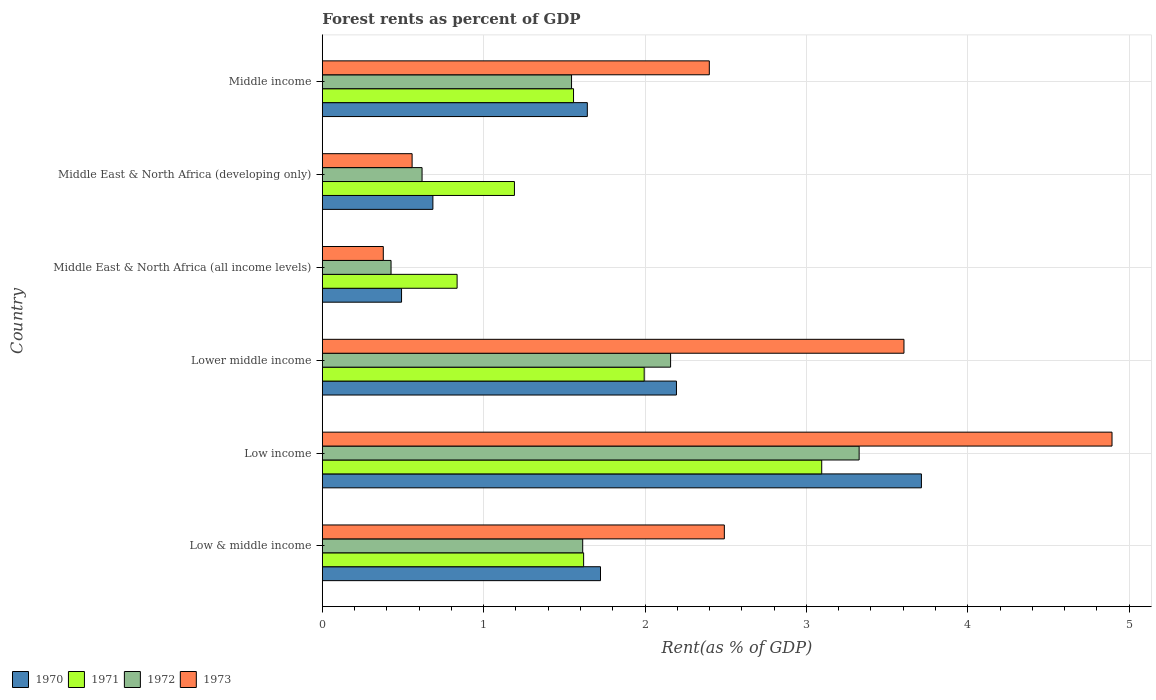Are the number of bars on each tick of the Y-axis equal?
Give a very brief answer. Yes. How many bars are there on the 1st tick from the top?
Give a very brief answer. 4. What is the label of the 3rd group of bars from the top?
Give a very brief answer. Middle East & North Africa (all income levels). What is the forest rent in 1970 in Middle East & North Africa (developing only)?
Your answer should be very brief. 0.69. Across all countries, what is the maximum forest rent in 1970?
Your response must be concise. 3.71. Across all countries, what is the minimum forest rent in 1971?
Provide a short and direct response. 0.84. In which country was the forest rent in 1973 minimum?
Your answer should be very brief. Middle East & North Africa (all income levels). What is the total forest rent in 1973 in the graph?
Your answer should be very brief. 14.32. What is the difference between the forest rent in 1973 in Low income and that in Middle East & North Africa (developing only)?
Provide a succinct answer. 4.34. What is the difference between the forest rent in 1972 in Lower middle income and the forest rent in 1970 in Middle East & North Africa (developing only)?
Give a very brief answer. 1.47. What is the average forest rent in 1970 per country?
Provide a short and direct response. 1.74. What is the difference between the forest rent in 1970 and forest rent in 1973 in Low & middle income?
Your answer should be compact. -0.77. What is the ratio of the forest rent in 1973 in Middle East & North Africa (all income levels) to that in Middle income?
Your answer should be very brief. 0.16. Is the forest rent in 1972 in Low & middle income less than that in Lower middle income?
Make the answer very short. Yes. Is the difference between the forest rent in 1970 in Low & middle income and Middle East & North Africa (developing only) greater than the difference between the forest rent in 1973 in Low & middle income and Middle East & North Africa (developing only)?
Your answer should be compact. No. What is the difference between the highest and the second highest forest rent in 1973?
Ensure brevity in your answer.  1.29. What is the difference between the highest and the lowest forest rent in 1972?
Your answer should be compact. 2.9. In how many countries, is the forest rent in 1973 greater than the average forest rent in 1973 taken over all countries?
Your answer should be compact. 4. Is the sum of the forest rent in 1973 in Low & middle income and Lower middle income greater than the maximum forest rent in 1970 across all countries?
Your response must be concise. Yes. Is it the case that in every country, the sum of the forest rent in 1972 and forest rent in 1971 is greater than the sum of forest rent in 1973 and forest rent in 1970?
Keep it short and to the point. No. What does the 2nd bar from the bottom in Low & middle income represents?
Provide a succinct answer. 1971. Is it the case that in every country, the sum of the forest rent in 1970 and forest rent in 1973 is greater than the forest rent in 1972?
Provide a succinct answer. Yes. Are all the bars in the graph horizontal?
Offer a very short reply. Yes. Does the graph contain any zero values?
Provide a succinct answer. No. Where does the legend appear in the graph?
Your response must be concise. Bottom left. How many legend labels are there?
Ensure brevity in your answer.  4. How are the legend labels stacked?
Ensure brevity in your answer.  Horizontal. What is the title of the graph?
Keep it short and to the point. Forest rents as percent of GDP. What is the label or title of the X-axis?
Ensure brevity in your answer.  Rent(as % of GDP). What is the Rent(as % of GDP) in 1970 in Low & middle income?
Provide a succinct answer. 1.72. What is the Rent(as % of GDP) of 1971 in Low & middle income?
Ensure brevity in your answer.  1.62. What is the Rent(as % of GDP) in 1972 in Low & middle income?
Offer a very short reply. 1.61. What is the Rent(as % of GDP) of 1973 in Low & middle income?
Give a very brief answer. 2.49. What is the Rent(as % of GDP) of 1970 in Low income?
Give a very brief answer. 3.71. What is the Rent(as % of GDP) of 1971 in Low income?
Keep it short and to the point. 3.09. What is the Rent(as % of GDP) in 1972 in Low income?
Your response must be concise. 3.33. What is the Rent(as % of GDP) of 1973 in Low income?
Make the answer very short. 4.89. What is the Rent(as % of GDP) in 1970 in Lower middle income?
Offer a very short reply. 2.19. What is the Rent(as % of GDP) in 1971 in Lower middle income?
Provide a succinct answer. 1.99. What is the Rent(as % of GDP) of 1972 in Lower middle income?
Offer a very short reply. 2.16. What is the Rent(as % of GDP) in 1973 in Lower middle income?
Make the answer very short. 3.6. What is the Rent(as % of GDP) in 1970 in Middle East & North Africa (all income levels)?
Your answer should be compact. 0.49. What is the Rent(as % of GDP) of 1971 in Middle East & North Africa (all income levels)?
Keep it short and to the point. 0.84. What is the Rent(as % of GDP) in 1972 in Middle East & North Africa (all income levels)?
Provide a succinct answer. 0.43. What is the Rent(as % of GDP) of 1973 in Middle East & North Africa (all income levels)?
Your response must be concise. 0.38. What is the Rent(as % of GDP) of 1970 in Middle East & North Africa (developing only)?
Offer a very short reply. 0.69. What is the Rent(as % of GDP) in 1971 in Middle East & North Africa (developing only)?
Make the answer very short. 1.19. What is the Rent(as % of GDP) of 1972 in Middle East & North Africa (developing only)?
Offer a terse response. 0.62. What is the Rent(as % of GDP) of 1973 in Middle East & North Africa (developing only)?
Offer a very short reply. 0.56. What is the Rent(as % of GDP) of 1970 in Middle income?
Give a very brief answer. 1.64. What is the Rent(as % of GDP) of 1971 in Middle income?
Your response must be concise. 1.56. What is the Rent(as % of GDP) in 1972 in Middle income?
Keep it short and to the point. 1.54. What is the Rent(as % of GDP) of 1973 in Middle income?
Give a very brief answer. 2.4. Across all countries, what is the maximum Rent(as % of GDP) in 1970?
Provide a succinct answer. 3.71. Across all countries, what is the maximum Rent(as % of GDP) in 1971?
Offer a terse response. 3.09. Across all countries, what is the maximum Rent(as % of GDP) of 1972?
Your answer should be very brief. 3.33. Across all countries, what is the maximum Rent(as % of GDP) of 1973?
Your response must be concise. 4.89. Across all countries, what is the minimum Rent(as % of GDP) in 1970?
Provide a short and direct response. 0.49. Across all countries, what is the minimum Rent(as % of GDP) in 1971?
Make the answer very short. 0.84. Across all countries, what is the minimum Rent(as % of GDP) of 1972?
Offer a terse response. 0.43. Across all countries, what is the minimum Rent(as % of GDP) of 1973?
Make the answer very short. 0.38. What is the total Rent(as % of GDP) of 1970 in the graph?
Provide a short and direct response. 10.45. What is the total Rent(as % of GDP) in 1971 in the graph?
Keep it short and to the point. 10.29. What is the total Rent(as % of GDP) of 1972 in the graph?
Offer a terse response. 9.69. What is the total Rent(as % of GDP) of 1973 in the graph?
Provide a succinct answer. 14.32. What is the difference between the Rent(as % of GDP) of 1970 in Low & middle income and that in Low income?
Provide a succinct answer. -1.99. What is the difference between the Rent(as % of GDP) of 1971 in Low & middle income and that in Low income?
Ensure brevity in your answer.  -1.48. What is the difference between the Rent(as % of GDP) in 1972 in Low & middle income and that in Low income?
Your answer should be very brief. -1.71. What is the difference between the Rent(as % of GDP) of 1973 in Low & middle income and that in Low income?
Your answer should be very brief. -2.4. What is the difference between the Rent(as % of GDP) in 1970 in Low & middle income and that in Lower middle income?
Your response must be concise. -0.47. What is the difference between the Rent(as % of GDP) in 1971 in Low & middle income and that in Lower middle income?
Give a very brief answer. -0.38. What is the difference between the Rent(as % of GDP) of 1972 in Low & middle income and that in Lower middle income?
Ensure brevity in your answer.  -0.54. What is the difference between the Rent(as % of GDP) of 1973 in Low & middle income and that in Lower middle income?
Ensure brevity in your answer.  -1.11. What is the difference between the Rent(as % of GDP) in 1970 in Low & middle income and that in Middle East & North Africa (all income levels)?
Make the answer very short. 1.23. What is the difference between the Rent(as % of GDP) in 1971 in Low & middle income and that in Middle East & North Africa (all income levels)?
Make the answer very short. 0.78. What is the difference between the Rent(as % of GDP) of 1972 in Low & middle income and that in Middle East & North Africa (all income levels)?
Your answer should be compact. 1.19. What is the difference between the Rent(as % of GDP) of 1973 in Low & middle income and that in Middle East & North Africa (all income levels)?
Ensure brevity in your answer.  2.11. What is the difference between the Rent(as % of GDP) of 1970 in Low & middle income and that in Middle East & North Africa (developing only)?
Provide a short and direct response. 1.04. What is the difference between the Rent(as % of GDP) in 1971 in Low & middle income and that in Middle East & North Africa (developing only)?
Your answer should be compact. 0.43. What is the difference between the Rent(as % of GDP) in 1973 in Low & middle income and that in Middle East & North Africa (developing only)?
Make the answer very short. 1.93. What is the difference between the Rent(as % of GDP) in 1970 in Low & middle income and that in Middle income?
Provide a succinct answer. 0.08. What is the difference between the Rent(as % of GDP) in 1971 in Low & middle income and that in Middle income?
Offer a very short reply. 0.06. What is the difference between the Rent(as % of GDP) of 1972 in Low & middle income and that in Middle income?
Your answer should be very brief. 0.07. What is the difference between the Rent(as % of GDP) of 1973 in Low & middle income and that in Middle income?
Offer a terse response. 0.09. What is the difference between the Rent(as % of GDP) in 1970 in Low income and that in Lower middle income?
Provide a succinct answer. 1.52. What is the difference between the Rent(as % of GDP) in 1971 in Low income and that in Lower middle income?
Your response must be concise. 1.1. What is the difference between the Rent(as % of GDP) of 1972 in Low income and that in Lower middle income?
Keep it short and to the point. 1.17. What is the difference between the Rent(as % of GDP) in 1973 in Low income and that in Lower middle income?
Your answer should be very brief. 1.29. What is the difference between the Rent(as % of GDP) in 1970 in Low income and that in Middle East & North Africa (all income levels)?
Your answer should be compact. 3.22. What is the difference between the Rent(as % of GDP) in 1971 in Low income and that in Middle East & North Africa (all income levels)?
Offer a very short reply. 2.26. What is the difference between the Rent(as % of GDP) of 1972 in Low income and that in Middle East & North Africa (all income levels)?
Give a very brief answer. 2.9. What is the difference between the Rent(as % of GDP) of 1973 in Low income and that in Middle East & North Africa (all income levels)?
Offer a very short reply. 4.52. What is the difference between the Rent(as % of GDP) of 1970 in Low income and that in Middle East & North Africa (developing only)?
Make the answer very short. 3.03. What is the difference between the Rent(as % of GDP) of 1971 in Low income and that in Middle East & North Africa (developing only)?
Provide a succinct answer. 1.9. What is the difference between the Rent(as % of GDP) of 1972 in Low income and that in Middle East & North Africa (developing only)?
Your response must be concise. 2.71. What is the difference between the Rent(as % of GDP) in 1973 in Low income and that in Middle East & North Africa (developing only)?
Your response must be concise. 4.34. What is the difference between the Rent(as % of GDP) of 1970 in Low income and that in Middle income?
Your answer should be compact. 2.07. What is the difference between the Rent(as % of GDP) of 1971 in Low income and that in Middle income?
Keep it short and to the point. 1.54. What is the difference between the Rent(as % of GDP) in 1972 in Low income and that in Middle income?
Offer a very short reply. 1.78. What is the difference between the Rent(as % of GDP) in 1973 in Low income and that in Middle income?
Offer a very short reply. 2.5. What is the difference between the Rent(as % of GDP) in 1970 in Lower middle income and that in Middle East & North Africa (all income levels)?
Ensure brevity in your answer.  1.7. What is the difference between the Rent(as % of GDP) of 1971 in Lower middle income and that in Middle East & North Africa (all income levels)?
Ensure brevity in your answer.  1.16. What is the difference between the Rent(as % of GDP) of 1972 in Lower middle income and that in Middle East & North Africa (all income levels)?
Ensure brevity in your answer.  1.73. What is the difference between the Rent(as % of GDP) of 1973 in Lower middle income and that in Middle East & North Africa (all income levels)?
Your response must be concise. 3.23. What is the difference between the Rent(as % of GDP) of 1970 in Lower middle income and that in Middle East & North Africa (developing only)?
Your response must be concise. 1.51. What is the difference between the Rent(as % of GDP) of 1971 in Lower middle income and that in Middle East & North Africa (developing only)?
Provide a short and direct response. 0.8. What is the difference between the Rent(as % of GDP) in 1972 in Lower middle income and that in Middle East & North Africa (developing only)?
Ensure brevity in your answer.  1.54. What is the difference between the Rent(as % of GDP) in 1973 in Lower middle income and that in Middle East & North Africa (developing only)?
Give a very brief answer. 3.05. What is the difference between the Rent(as % of GDP) of 1970 in Lower middle income and that in Middle income?
Ensure brevity in your answer.  0.55. What is the difference between the Rent(as % of GDP) in 1971 in Lower middle income and that in Middle income?
Provide a succinct answer. 0.44. What is the difference between the Rent(as % of GDP) of 1972 in Lower middle income and that in Middle income?
Provide a succinct answer. 0.61. What is the difference between the Rent(as % of GDP) in 1973 in Lower middle income and that in Middle income?
Provide a short and direct response. 1.21. What is the difference between the Rent(as % of GDP) of 1970 in Middle East & North Africa (all income levels) and that in Middle East & North Africa (developing only)?
Offer a terse response. -0.19. What is the difference between the Rent(as % of GDP) in 1971 in Middle East & North Africa (all income levels) and that in Middle East & North Africa (developing only)?
Provide a succinct answer. -0.36. What is the difference between the Rent(as % of GDP) in 1972 in Middle East & North Africa (all income levels) and that in Middle East & North Africa (developing only)?
Keep it short and to the point. -0.19. What is the difference between the Rent(as % of GDP) of 1973 in Middle East & North Africa (all income levels) and that in Middle East & North Africa (developing only)?
Offer a very short reply. -0.18. What is the difference between the Rent(as % of GDP) of 1970 in Middle East & North Africa (all income levels) and that in Middle income?
Ensure brevity in your answer.  -1.15. What is the difference between the Rent(as % of GDP) of 1971 in Middle East & North Africa (all income levels) and that in Middle income?
Provide a short and direct response. -0.72. What is the difference between the Rent(as % of GDP) in 1972 in Middle East & North Africa (all income levels) and that in Middle income?
Give a very brief answer. -1.12. What is the difference between the Rent(as % of GDP) of 1973 in Middle East & North Africa (all income levels) and that in Middle income?
Offer a terse response. -2.02. What is the difference between the Rent(as % of GDP) in 1970 in Middle East & North Africa (developing only) and that in Middle income?
Give a very brief answer. -0.96. What is the difference between the Rent(as % of GDP) of 1971 in Middle East & North Africa (developing only) and that in Middle income?
Keep it short and to the point. -0.37. What is the difference between the Rent(as % of GDP) of 1972 in Middle East & North Africa (developing only) and that in Middle income?
Ensure brevity in your answer.  -0.93. What is the difference between the Rent(as % of GDP) of 1973 in Middle East & North Africa (developing only) and that in Middle income?
Provide a succinct answer. -1.84. What is the difference between the Rent(as % of GDP) of 1970 in Low & middle income and the Rent(as % of GDP) of 1971 in Low income?
Make the answer very short. -1.37. What is the difference between the Rent(as % of GDP) of 1970 in Low & middle income and the Rent(as % of GDP) of 1972 in Low income?
Give a very brief answer. -1.6. What is the difference between the Rent(as % of GDP) of 1970 in Low & middle income and the Rent(as % of GDP) of 1973 in Low income?
Your response must be concise. -3.17. What is the difference between the Rent(as % of GDP) of 1971 in Low & middle income and the Rent(as % of GDP) of 1972 in Low income?
Ensure brevity in your answer.  -1.71. What is the difference between the Rent(as % of GDP) of 1971 in Low & middle income and the Rent(as % of GDP) of 1973 in Low income?
Offer a very short reply. -3.27. What is the difference between the Rent(as % of GDP) in 1972 in Low & middle income and the Rent(as % of GDP) in 1973 in Low income?
Offer a very short reply. -3.28. What is the difference between the Rent(as % of GDP) in 1970 in Low & middle income and the Rent(as % of GDP) in 1971 in Lower middle income?
Give a very brief answer. -0.27. What is the difference between the Rent(as % of GDP) of 1970 in Low & middle income and the Rent(as % of GDP) of 1972 in Lower middle income?
Ensure brevity in your answer.  -0.43. What is the difference between the Rent(as % of GDP) of 1970 in Low & middle income and the Rent(as % of GDP) of 1973 in Lower middle income?
Ensure brevity in your answer.  -1.88. What is the difference between the Rent(as % of GDP) in 1971 in Low & middle income and the Rent(as % of GDP) in 1972 in Lower middle income?
Provide a succinct answer. -0.54. What is the difference between the Rent(as % of GDP) in 1971 in Low & middle income and the Rent(as % of GDP) in 1973 in Lower middle income?
Make the answer very short. -1.99. What is the difference between the Rent(as % of GDP) in 1972 in Low & middle income and the Rent(as % of GDP) in 1973 in Lower middle income?
Provide a short and direct response. -1.99. What is the difference between the Rent(as % of GDP) of 1970 in Low & middle income and the Rent(as % of GDP) of 1971 in Middle East & North Africa (all income levels)?
Offer a very short reply. 0.89. What is the difference between the Rent(as % of GDP) of 1970 in Low & middle income and the Rent(as % of GDP) of 1972 in Middle East & North Africa (all income levels)?
Make the answer very short. 1.3. What is the difference between the Rent(as % of GDP) of 1970 in Low & middle income and the Rent(as % of GDP) of 1973 in Middle East & North Africa (all income levels)?
Your answer should be very brief. 1.35. What is the difference between the Rent(as % of GDP) of 1971 in Low & middle income and the Rent(as % of GDP) of 1972 in Middle East & North Africa (all income levels)?
Your response must be concise. 1.19. What is the difference between the Rent(as % of GDP) in 1971 in Low & middle income and the Rent(as % of GDP) in 1973 in Middle East & North Africa (all income levels)?
Make the answer very short. 1.24. What is the difference between the Rent(as % of GDP) in 1972 in Low & middle income and the Rent(as % of GDP) in 1973 in Middle East & North Africa (all income levels)?
Your response must be concise. 1.24. What is the difference between the Rent(as % of GDP) of 1970 in Low & middle income and the Rent(as % of GDP) of 1971 in Middle East & North Africa (developing only)?
Provide a succinct answer. 0.53. What is the difference between the Rent(as % of GDP) in 1970 in Low & middle income and the Rent(as % of GDP) in 1972 in Middle East & North Africa (developing only)?
Your answer should be compact. 1.11. What is the difference between the Rent(as % of GDP) of 1970 in Low & middle income and the Rent(as % of GDP) of 1973 in Middle East & North Africa (developing only)?
Offer a terse response. 1.17. What is the difference between the Rent(as % of GDP) of 1971 in Low & middle income and the Rent(as % of GDP) of 1972 in Middle East & North Africa (developing only)?
Make the answer very short. 1. What is the difference between the Rent(as % of GDP) in 1971 in Low & middle income and the Rent(as % of GDP) in 1973 in Middle East & North Africa (developing only)?
Give a very brief answer. 1.06. What is the difference between the Rent(as % of GDP) of 1972 in Low & middle income and the Rent(as % of GDP) of 1973 in Middle East & North Africa (developing only)?
Give a very brief answer. 1.06. What is the difference between the Rent(as % of GDP) in 1970 in Low & middle income and the Rent(as % of GDP) in 1971 in Middle income?
Give a very brief answer. 0.17. What is the difference between the Rent(as % of GDP) in 1970 in Low & middle income and the Rent(as % of GDP) in 1972 in Middle income?
Your answer should be compact. 0.18. What is the difference between the Rent(as % of GDP) of 1970 in Low & middle income and the Rent(as % of GDP) of 1973 in Middle income?
Offer a very short reply. -0.67. What is the difference between the Rent(as % of GDP) in 1971 in Low & middle income and the Rent(as % of GDP) in 1972 in Middle income?
Offer a very short reply. 0.07. What is the difference between the Rent(as % of GDP) of 1971 in Low & middle income and the Rent(as % of GDP) of 1973 in Middle income?
Offer a terse response. -0.78. What is the difference between the Rent(as % of GDP) of 1972 in Low & middle income and the Rent(as % of GDP) of 1973 in Middle income?
Offer a very short reply. -0.78. What is the difference between the Rent(as % of GDP) of 1970 in Low income and the Rent(as % of GDP) of 1971 in Lower middle income?
Your answer should be compact. 1.72. What is the difference between the Rent(as % of GDP) of 1970 in Low income and the Rent(as % of GDP) of 1972 in Lower middle income?
Offer a terse response. 1.55. What is the difference between the Rent(as % of GDP) in 1970 in Low income and the Rent(as % of GDP) in 1973 in Lower middle income?
Keep it short and to the point. 0.11. What is the difference between the Rent(as % of GDP) in 1971 in Low income and the Rent(as % of GDP) in 1972 in Lower middle income?
Your answer should be compact. 0.94. What is the difference between the Rent(as % of GDP) of 1971 in Low income and the Rent(as % of GDP) of 1973 in Lower middle income?
Provide a succinct answer. -0.51. What is the difference between the Rent(as % of GDP) in 1972 in Low income and the Rent(as % of GDP) in 1973 in Lower middle income?
Offer a very short reply. -0.28. What is the difference between the Rent(as % of GDP) of 1970 in Low income and the Rent(as % of GDP) of 1971 in Middle East & North Africa (all income levels)?
Offer a very short reply. 2.88. What is the difference between the Rent(as % of GDP) of 1970 in Low income and the Rent(as % of GDP) of 1972 in Middle East & North Africa (all income levels)?
Offer a terse response. 3.29. What is the difference between the Rent(as % of GDP) of 1970 in Low income and the Rent(as % of GDP) of 1973 in Middle East & North Africa (all income levels)?
Make the answer very short. 3.33. What is the difference between the Rent(as % of GDP) of 1971 in Low income and the Rent(as % of GDP) of 1972 in Middle East & North Africa (all income levels)?
Provide a succinct answer. 2.67. What is the difference between the Rent(as % of GDP) of 1971 in Low income and the Rent(as % of GDP) of 1973 in Middle East & North Africa (all income levels)?
Provide a succinct answer. 2.72. What is the difference between the Rent(as % of GDP) of 1972 in Low income and the Rent(as % of GDP) of 1973 in Middle East & North Africa (all income levels)?
Your answer should be very brief. 2.95. What is the difference between the Rent(as % of GDP) of 1970 in Low income and the Rent(as % of GDP) of 1971 in Middle East & North Africa (developing only)?
Make the answer very short. 2.52. What is the difference between the Rent(as % of GDP) of 1970 in Low income and the Rent(as % of GDP) of 1972 in Middle East & North Africa (developing only)?
Keep it short and to the point. 3.09. What is the difference between the Rent(as % of GDP) of 1970 in Low income and the Rent(as % of GDP) of 1973 in Middle East & North Africa (developing only)?
Keep it short and to the point. 3.16. What is the difference between the Rent(as % of GDP) in 1971 in Low income and the Rent(as % of GDP) in 1972 in Middle East & North Africa (developing only)?
Keep it short and to the point. 2.48. What is the difference between the Rent(as % of GDP) in 1971 in Low income and the Rent(as % of GDP) in 1973 in Middle East & North Africa (developing only)?
Offer a terse response. 2.54. What is the difference between the Rent(as % of GDP) in 1972 in Low income and the Rent(as % of GDP) in 1973 in Middle East & North Africa (developing only)?
Ensure brevity in your answer.  2.77. What is the difference between the Rent(as % of GDP) in 1970 in Low income and the Rent(as % of GDP) in 1971 in Middle income?
Your answer should be very brief. 2.16. What is the difference between the Rent(as % of GDP) of 1970 in Low income and the Rent(as % of GDP) of 1972 in Middle income?
Your answer should be compact. 2.17. What is the difference between the Rent(as % of GDP) in 1970 in Low income and the Rent(as % of GDP) in 1973 in Middle income?
Ensure brevity in your answer.  1.31. What is the difference between the Rent(as % of GDP) of 1971 in Low income and the Rent(as % of GDP) of 1972 in Middle income?
Offer a terse response. 1.55. What is the difference between the Rent(as % of GDP) of 1971 in Low income and the Rent(as % of GDP) of 1973 in Middle income?
Offer a terse response. 0.7. What is the difference between the Rent(as % of GDP) of 1972 in Low income and the Rent(as % of GDP) of 1973 in Middle income?
Offer a terse response. 0.93. What is the difference between the Rent(as % of GDP) of 1970 in Lower middle income and the Rent(as % of GDP) of 1971 in Middle East & North Africa (all income levels)?
Make the answer very short. 1.36. What is the difference between the Rent(as % of GDP) in 1970 in Lower middle income and the Rent(as % of GDP) in 1972 in Middle East & North Africa (all income levels)?
Offer a terse response. 1.77. What is the difference between the Rent(as % of GDP) of 1970 in Lower middle income and the Rent(as % of GDP) of 1973 in Middle East & North Africa (all income levels)?
Offer a very short reply. 1.82. What is the difference between the Rent(as % of GDP) of 1971 in Lower middle income and the Rent(as % of GDP) of 1972 in Middle East & North Africa (all income levels)?
Offer a terse response. 1.57. What is the difference between the Rent(as % of GDP) of 1971 in Lower middle income and the Rent(as % of GDP) of 1973 in Middle East & North Africa (all income levels)?
Offer a very short reply. 1.62. What is the difference between the Rent(as % of GDP) in 1972 in Lower middle income and the Rent(as % of GDP) in 1973 in Middle East & North Africa (all income levels)?
Make the answer very short. 1.78. What is the difference between the Rent(as % of GDP) of 1970 in Lower middle income and the Rent(as % of GDP) of 1971 in Middle East & North Africa (developing only)?
Your answer should be compact. 1. What is the difference between the Rent(as % of GDP) in 1970 in Lower middle income and the Rent(as % of GDP) in 1972 in Middle East & North Africa (developing only)?
Give a very brief answer. 1.58. What is the difference between the Rent(as % of GDP) in 1970 in Lower middle income and the Rent(as % of GDP) in 1973 in Middle East & North Africa (developing only)?
Offer a very short reply. 1.64. What is the difference between the Rent(as % of GDP) of 1971 in Lower middle income and the Rent(as % of GDP) of 1972 in Middle East & North Africa (developing only)?
Your response must be concise. 1.38. What is the difference between the Rent(as % of GDP) of 1971 in Lower middle income and the Rent(as % of GDP) of 1973 in Middle East & North Africa (developing only)?
Provide a succinct answer. 1.44. What is the difference between the Rent(as % of GDP) of 1972 in Lower middle income and the Rent(as % of GDP) of 1973 in Middle East & North Africa (developing only)?
Your response must be concise. 1.6. What is the difference between the Rent(as % of GDP) in 1970 in Lower middle income and the Rent(as % of GDP) in 1971 in Middle income?
Keep it short and to the point. 0.64. What is the difference between the Rent(as % of GDP) of 1970 in Lower middle income and the Rent(as % of GDP) of 1972 in Middle income?
Your answer should be very brief. 0.65. What is the difference between the Rent(as % of GDP) of 1970 in Lower middle income and the Rent(as % of GDP) of 1973 in Middle income?
Provide a succinct answer. -0.2. What is the difference between the Rent(as % of GDP) of 1971 in Lower middle income and the Rent(as % of GDP) of 1972 in Middle income?
Offer a terse response. 0.45. What is the difference between the Rent(as % of GDP) in 1971 in Lower middle income and the Rent(as % of GDP) in 1973 in Middle income?
Your response must be concise. -0.4. What is the difference between the Rent(as % of GDP) in 1972 in Lower middle income and the Rent(as % of GDP) in 1973 in Middle income?
Your response must be concise. -0.24. What is the difference between the Rent(as % of GDP) in 1970 in Middle East & North Africa (all income levels) and the Rent(as % of GDP) in 1971 in Middle East & North Africa (developing only)?
Provide a succinct answer. -0.7. What is the difference between the Rent(as % of GDP) in 1970 in Middle East & North Africa (all income levels) and the Rent(as % of GDP) in 1972 in Middle East & North Africa (developing only)?
Your response must be concise. -0.13. What is the difference between the Rent(as % of GDP) of 1970 in Middle East & North Africa (all income levels) and the Rent(as % of GDP) of 1973 in Middle East & North Africa (developing only)?
Keep it short and to the point. -0.07. What is the difference between the Rent(as % of GDP) in 1971 in Middle East & North Africa (all income levels) and the Rent(as % of GDP) in 1972 in Middle East & North Africa (developing only)?
Offer a very short reply. 0.22. What is the difference between the Rent(as % of GDP) in 1971 in Middle East & North Africa (all income levels) and the Rent(as % of GDP) in 1973 in Middle East & North Africa (developing only)?
Provide a succinct answer. 0.28. What is the difference between the Rent(as % of GDP) of 1972 in Middle East & North Africa (all income levels) and the Rent(as % of GDP) of 1973 in Middle East & North Africa (developing only)?
Your answer should be compact. -0.13. What is the difference between the Rent(as % of GDP) of 1970 in Middle East & North Africa (all income levels) and the Rent(as % of GDP) of 1971 in Middle income?
Make the answer very short. -1.07. What is the difference between the Rent(as % of GDP) of 1970 in Middle East & North Africa (all income levels) and the Rent(as % of GDP) of 1972 in Middle income?
Provide a succinct answer. -1.05. What is the difference between the Rent(as % of GDP) in 1970 in Middle East & North Africa (all income levels) and the Rent(as % of GDP) in 1973 in Middle income?
Your answer should be compact. -1.91. What is the difference between the Rent(as % of GDP) of 1971 in Middle East & North Africa (all income levels) and the Rent(as % of GDP) of 1972 in Middle income?
Keep it short and to the point. -0.71. What is the difference between the Rent(as % of GDP) in 1971 in Middle East & North Africa (all income levels) and the Rent(as % of GDP) in 1973 in Middle income?
Offer a very short reply. -1.56. What is the difference between the Rent(as % of GDP) in 1972 in Middle East & North Africa (all income levels) and the Rent(as % of GDP) in 1973 in Middle income?
Offer a terse response. -1.97. What is the difference between the Rent(as % of GDP) of 1970 in Middle East & North Africa (developing only) and the Rent(as % of GDP) of 1971 in Middle income?
Offer a very short reply. -0.87. What is the difference between the Rent(as % of GDP) in 1970 in Middle East & North Africa (developing only) and the Rent(as % of GDP) in 1972 in Middle income?
Provide a short and direct response. -0.86. What is the difference between the Rent(as % of GDP) of 1970 in Middle East & North Africa (developing only) and the Rent(as % of GDP) of 1973 in Middle income?
Your answer should be compact. -1.71. What is the difference between the Rent(as % of GDP) of 1971 in Middle East & North Africa (developing only) and the Rent(as % of GDP) of 1972 in Middle income?
Your answer should be very brief. -0.35. What is the difference between the Rent(as % of GDP) in 1971 in Middle East & North Africa (developing only) and the Rent(as % of GDP) in 1973 in Middle income?
Keep it short and to the point. -1.21. What is the difference between the Rent(as % of GDP) in 1972 in Middle East & North Africa (developing only) and the Rent(as % of GDP) in 1973 in Middle income?
Offer a terse response. -1.78. What is the average Rent(as % of GDP) of 1970 per country?
Give a very brief answer. 1.74. What is the average Rent(as % of GDP) of 1971 per country?
Offer a very short reply. 1.72. What is the average Rent(as % of GDP) of 1972 per country?
Keep it short and to the point. 1.61. What is the average Rent(as % of GDP) in 1973 per country?
Offer a very short reply. 2.39. What is the difference between the Rent(as % of GDP) in 1970 and Rent(as % of GDP) in 1971 in Low & middle income?
Provide a short and direct response. 0.1. What is the difference between the Rent(as % of GDP) of 1970 and Rent(as % of GDP) of 1972 in Low & middle income?
Provide a succinct answer. 0.11. What is the difference between the Rent(as % of GDP) of 1970 and Rent(as % of GDP) of 1973 in Low & middle income?
Your response must be concise. -0.77. What is the difference between the Rent(as % of GDP) in 1971 and Rent(as % of GDP) in 1972 in Low & middle income?
Your answer should be very brief. 0.01. What is the difference between the Rent(as % of GDP) in 1971 and Rent(as % of GDP) in 1973 in Low & middle income?
Your response must be concise. -0.87. What is the difference between the Rent(as % of GDP) in 1972 and Rent(as % of GDP) in 1973 in Low & middle income?
Provide a short and direct response. -0.88. What is the difference between the Rent(as % of GDP) in 1970 and Rent(as % of GDP) in 1971 in Low income?
Make the answer very short. 0.62. What is the difference between the Rent(as % of GDP) in 1970 and Rent(as % of GDP) in 1972 in Low income?
Keep it short and to the point. 0.39. What is the difference between the Rent(as % of GDP) in 1970 and Rent(as % of GDP) in 1973 in Low income?
Give a very brief answer. -1.18. What is the difference between the Rent(as % of GDP) of 1971 and Rent(as % of GDP) of 1972 in Low income?
Your answer should be compact. -0.23. What is the difference between the Rent(as % of GDP) of 1971 and Rent(as % of GDP) of 1973 in Low income?
Give a very brief answer. -1.8. What is the difference between the Rent(as % of GDP) in 1972 and Rent(as % of GDP) in 1973 in Low income?
Offer a terse response. -1.57. What is the difference between the Rent(as % of GDP) of 1970 and Rent(as % of GDP) of 1971 in Lower middle income?
Keep it short and to the point. 0.2. What is the difference between the Rent(as % of GDP) of 1970 and Rent(as % of GDP) of 1972 in Lower middle income?
Your response must be concise. 0.04. What is the difference between the Rent(as % of GDP) of 1970 and Rent(as % of GDP) of 1973 in Lower middle income?
Your answer should be compact. -1.41. What is the difference between the Rent(as % of GDP) of 1971 and Rent(as % of GDP) of 1972 in Lower middle income?
Provide a short and direct response. -0.16. What is the difference between the Rent(as % of GDP) in 1971 and Rent(as % of GDP) in 1973 in Lower middle income?
Keep it short and to the point. -1.61. What is the difference between the Rent(as % of GDP) in 1972 and Rent(as % of GDP) in 1973 in Lower middle income?
Your response must be concise. -1.45. What is the difference between the Rent(as % of GDP) of 1970 and Rent(as % of GDP) of 1971 in Middle East & North Africa (all income levels)?
Provide a short and direct response. -0.34. What is the difference between the Rent(as % of GDP) in 1970 and Rent(as % of GDP) in 1972 in Middle East & North Africa (all income levels)?
Offer a terse response. 0.07. What is the difference between the Rent(as % of GDP) in 1970 and Rent(as % of GDP) in 1973 in Middle East & North Africa (all income levels)?
Make the answer very short. 0.11. What is the difference between the Rent(as % of GDP) of 1971 and Rent(as % of GDP) of 1972 in Middle East & North Africa (all income levels)?
Your answer should be compact. 0.41. What is the difference between the Rent(as % of GDP) of 1971 and Rent(as % of GDP) of 1973 in Middle East & North Africa (all income levels)?
Provide a short and direct response. 0.46. What is the difference between the Rent(as % of GDP) in 1972 and Rent(as % of GDP) in 1973 in Middle East & North Africa (all income levels)?
Ensure brevity in your answer.  0.05. What is the difference between the Rent(as % of GDP) in 1970 and Rent(as % of GDP) in 1971 in Middle East & North Africa (developing only)?
Make the answer very short. -0.51. What is the difference between the Rent(as % of GDP) of 1970 and Rent(as % of GDP) of 1972 in Middle East & North Africa (developing only)?
Offer a very short reply. 0.07. What is the difference between the Rent(as % of GDP) in 1970 and Rent(as % of GDP) in 1973 in Middle East & North Africa (developing only)?
Keep it short and to the point. 0.13. What is the difference between the Rent(as % of GDP) of 1971 and Rent(as % of GDP) of 1972 in Middle East & North Africa (developing only)?
Your answer should be very brief. 0.57. What is the difference between the Rent(as % of GDP) of 1971 and Rent(as % of GDP) of 1973 in Middle East & North Africa (developing only)?
Make the answer very short. 0.63. What is the difference between the Rent(as % of GDP) of 1972 and Rent(as % of GDP) of 1973 in Middle East & North Africa (developing only)?
Ensure brevity in your answer.  0.06. What is the difference between the Rent(as % of GDP) of 1970 and Rent(as % of GDP) of 1971 in Middle income?
Your answer should be compact. 0.09. What is the difference between the Rent(as % of GDP) of 1970 and Rent(as % of GDP) of 1972 in Middle income?
Keep it short and to the point. 0.1. What is the difference between the Rent(as % of GDP) in 1970 and Rent(as % of GDP) in 1973 in Middle income?
Ensure brevity in your answer.  -0.76. What is the difference between the Rent(as % of GDP) of 1971 and Rent(as % of GDP) of 1972 in Middle income?
Keep it short and to the point. 0.01. What is the difference between the Rent(as % of GDP) of 1971 and Rent(as % of GDP) of 1973 in Middle income?
Keep it short and to the point. -0.84. What is the difference between the Rent(as % of GDP) in 1972 and Rent(as % of GDP) in 1973 in Middle income?
Your answer should be compact. -0.85. What is the ratio of the Rent(as % of GDP) in 1970 in Low & middle income to that in Low income?
Your response must be concise. 0.46. What is the ratio of the Rent(as % of GDP) in 1971 in Low & middle income to that in Low income?
Provide a succinct answer. 0.52. What is the ratio of the Rent(as % of GDP) in 1972 in Low & middle income to that in Low income?
Make the answer very short. 0.48. What is the ratio of the Rent(as % of GDP) of 1973 in Low & middle income to that in Low income?
Give a very brief answer. 0.51. What is the ratio of the Rent(as % of GDP) in 1970 in Low & middle income to that in Lower middle income?
Offer a terse response. 0.79. What is the ratio of the Rent(as % of GDP) of 1971 in Low & middle income to that in Lower middle income?
Offer a terse response. 0.81. What is the ratio of the Rent(as % of GDP) in 1972 in Low & middle income to that in Lower middle income?
Keep it short and to the point. 0.75. What is the ratio of the Rent(as % of GDP) in 1973 in Low & middle income to that in Lower middle income?
Your answer should be compact. 0.69. What is the ratio of the Rent(as % of GDP) in 1970 in Low & middle income to that in Middle East & North Africa (all income levels)?
Ensure brevity in your answer.  3.51. What is the ratio of the Rent(as % of GDP) of 1971 in Low & middle income to that in Middle East & North Africa (all income levels)?
Make the answer very short. 1.94. What is the ratio of the Rent(as % of GDP) in 1972 in Low & middle income to that in Middle East & North Africa (all income levels)?
Your answer should be compact. 3.79. What is the ratio of the Rent(as % of GDP) of 1973 in Low & middle income to that in Middle East & North Africa (all income levels)?
Your response must be concise. 6.59. What is the ratio of the Rent(as % of GDP) in 1970 in Low & middle income to that in Middle East & North Africa (developing only)?
Your answer should be compact. 2.52. What is the ratio of the Rent(as % of GDP) in 1971 in Low & middle income to that in Middle East & North Africa (developing only)?
Offer a very short reply. 1.36. What is the ratio of the Rent(as % of GDP) of 1972 in Low & middle income to that in Middle East & North Africa (developing only)?
Keep it short and to the point. 2.61. What is the ratio of the Rent(as % of GDP) of 1973 in Low & middle income to that in Middle East & North Africa (developing only)?
Your answer should be very brief. 4.48. What is the ratio of the Rent(as % of GDP) of 1970 in Low & middle income to that in Middle income?
Offer a very short reply. 1.05. What is the ratio of the Rent(as % of GDP) of 1971 in Low & middle income to that in Middle income?
Keep it short and to the point. 1.04. What is the ratio of the Rent(as % of GDP) in 1972 in Low & middle income to that in Middle income?
Ensure brevity in your answer.  1.04. What is the ratio of the Rent(as % of GDP) of 1973 in Low & middle income to that in Middle income?
Keep it short and to the point. 1.04. What is the ratio of the Rent(as % of GDP) of 1970 in Low income to that in Lower middle income?
Your answer should be compact. 1.69. What is the ratio of the Rent(as % of GDP) in 1971 in Low income to that in Lower middle income?
Provide a succinct answer. 1.55. What is the ratio of the Rent(as % of GDP) in 1972 in Low income to that in Lower middle income?
Offer a very short reply. 1.54. What is the ratio of the Rent(as % of GDP) of 1973 in Low income to that in Lower middle income?
Give a very brief answer. 1.36. What is the ratio of the Rent(as % of GDP) of 1970 in Low income to that in Middle East & North Africa (all income levels)?
Your answer should be very brief. 7.56. What is the ratio of the Rent(as % of GDP) in 1971 in Low income to that in Middle East & North Africa (all income levels)?
Your answer should be compact. 3.71. What is the ratio of the Rent(as % of GDP) in 1972 in Low income to that in Middle East & North Africa (all income levels)?
Ensure brevity in your answer.  7.81. What is the ratio of the Rent(as % of GDP) of 1973 in Low income to that in Middle East & North Africa (all income levels)?
Provide a short and direct response. 12.95. What is the ratio of the Rent(as % of GDP) of 1970 in Low income to that in Middle East & North Africa (developing only)?
Keep it short and to the point. 5.42. What is the ratio of the Rent(as % of GDP) in 1971 in Low income to that in Middle East & North Africa (developing only)?
Provide a short and direct response. 2.6. What is the ratio of the Rent(as % of GDP) in 1972 in Low income to that in Middle East & North Africa (developing only)?
Make the answer very short. 5.38. What is the ratio of the Rent(as % of GDP) of 1973 in Low income to that in Middle East & North Africa (developing only)?
Give a very brief answer. 8.8. What is the ratio of the Rent(as % of GDP) of 1970 in Low income to that in Middle income?
Provide a succinct answer. 2.26. What is the ratio of the Rent(as % of GDP) of 1971 in Low income to that in Middle income?
Your answer should be compact. 1.99. What is the ratio of the Rent(as % of GDP) of 1972 in Low income to that in Middle income?
Keep it short and to the point. 2.15. What is the ratio of the Rent(as % of GDP) in 1973 in Low income to that in Middle income?
Provide a short and direct response. 2.04. What is the ratio of the Rent(as % of GDP) in 1970 in Lower middle income to that in Middle East & North Africa (all income levels)?
Give a very brief answer. 4.47. What is the ratio of the Rent(as % of GDP) in 1971 in Lower middle income to that in Middle East & North Africa (all income levels)?
Provide a succinct answer. 2.39. What is the ratio of the Rent(as % of GDP) in 1972 in Lower middle income to that in Middle East & North Africa (all income levels)?
Offer a very short reply. 5.07. What is the ratio of the Rent(as % of GDP) in 1973 in Lower middle income to that in Middle East & North Africa (all income levels)?
Your answer should be very brief. 9.54. What is the ratio of the Rent(as % of GDP) of 1970 in Lower middle income to that in Middle East & North Africa (developing only)?
Provide a short and direct response. 3.2. What is the ratio of the Rent(as % of GDP) of 1971 in Lower middle income to that in Middle East & North Africa (developing only)?
Give a very brief answer. 1.68. What is the ratio of the Rent(as % of GDP) of 1972 in Lower middle income to that in Middle East & North Africa (developing only)?
Provide a short and direct response. 3.49. What is the ratio of the Rent(as % of GDP) in 1973 in Lower middle income to that in Middle East & North Africa (developing only)?
Provide a succinct answer. 6.48. What is the ratio of the Rent(as % of GDP) in 1970 in Lower middle income to that in Middle income?
Make the answer very short. 1.34. What is the ratio of the Rent(as % of GDP) in 1971 in Lower middle income to that in Middle income?
Keep it short and to the point. 1.28. What is the ratio of the Rent(as % of GDP) of 1972 in Lower middle income to that in Middle income?
Your response must be concise. 1.4. What is the ratio of the Rent(as % of GDP) of 1973 in Lower middle income to that in Middle income?
Provide a short and direct response. 1.5. What is the ratio of the Rent(as % of GDP) in 1970 in Middle East & North Africa (all income levels) to that in Middle East & North Africa (developing only)?
Make the answer very short. 0.72. What is the ratio of the Rent(as % of GDP) in 1971 in Middle East & North Africa (all income levels) to that in Middle East & North Africa (developing only)?
Offer a very short reply. 0.7. What is the ratio of the Rent(as % of GDP) in 1972 in Middle East & North Africa (all income levels) to that in Middle East & North Africa (developing only)?
Offer a very short reply. 0.69. What is the ratio of the Rent(as % of GDP) of 1973 in Middle East & North Africa (all income levels) to that in Middle East & North Africa (developing only)?
Your response must be concise. 0.68. What is the ratio of the Rent(as % of GDP) of 1970 in Middle East & North Africa (all income levels) to that in Middle income?
Provide a short and direct response. 0.3. What is the ratio of the Rent(as % of GDP) of 1971 in Middle East & North Africa (all income levels) to that in Middle income?
Make the answer very short. 0.54. What is the ratio of the Rent(as % of GDP) of 1972 in Middle East & North Africa (all income levels) to that in Middle income?
Your answer should be very brief. 0.28. What is the ratio of the Rent(as % of GDP) of 1973 in Middle East & North Africa (all income levels) to that in Middle income?
Your response must be concise. 0.16. What is the ratio of the Rent(as % of GDP) of 1970 in Middle East & North Africa (developing only) to that in Middle income?
Your response must be concise. 0.42. What is the ratio of the Rent(as % of GDP) in 1971 in Middle East & North Africa (developing only) to that in Middle income?
Your answer should be very brief. 0.76. What is the ratio of the Rent(as % of GDP) in 1972 in Middle East & North Africa (developing only) to that in Middle income?
Your answer should be compact. 0.4. What is the ratio of the Rent(as % of GDP) of 1973 in Middle East & North Africa (developing only) to that in Middle income?
Your answer should be very brief. 0.23. What is the difference between the highest and the second highest Rent(as % of GDP) of 1970?
Make the answer very short. 1.52. What is the difference between the highest and the second highest Rent(as % of GDP) of 1971?
Offer a very short reply. 1.1. What is the difference between the highest and the second highest Rent(as % of GDP) of 1972?
Give a very brief answer. 1.17. What is the difference between the highest and the second highest Rent(as % of GDP) of 1973?
Ensure brevity in your answer.  1.29. What is the difference between the highest and the lowest Rent(as % of GDP) of 1970?
Your response must be concise. 3.22. What is the difference between the highest and the lowest Rent(as % of GDP) in 1971?
Offer a terse response. 2.26. What is the difference between the highest and the lowest Rent(as % of GDP) of 1972?
Your response must be concise. 2.9. What is the difference between the highest and the lowest Rent(as % of GDP) in 1973?
Offer a terse response. 4.52. 